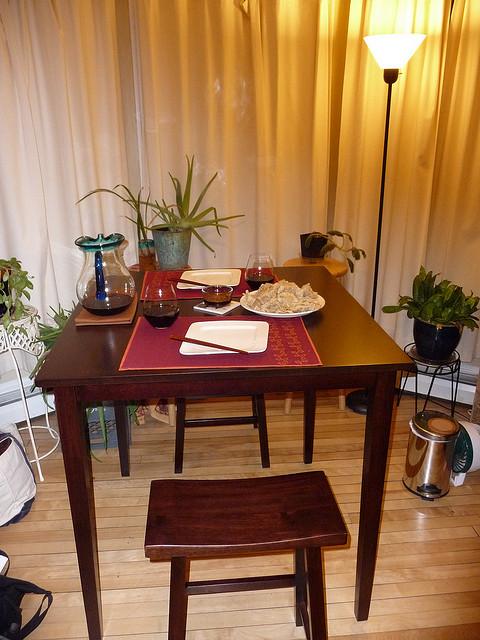Why are the plates square?
Answer briefly. Design. Is this a plain room?
Answer briefly. No. How many people could sit at this table?
Answer briefly. 2. 